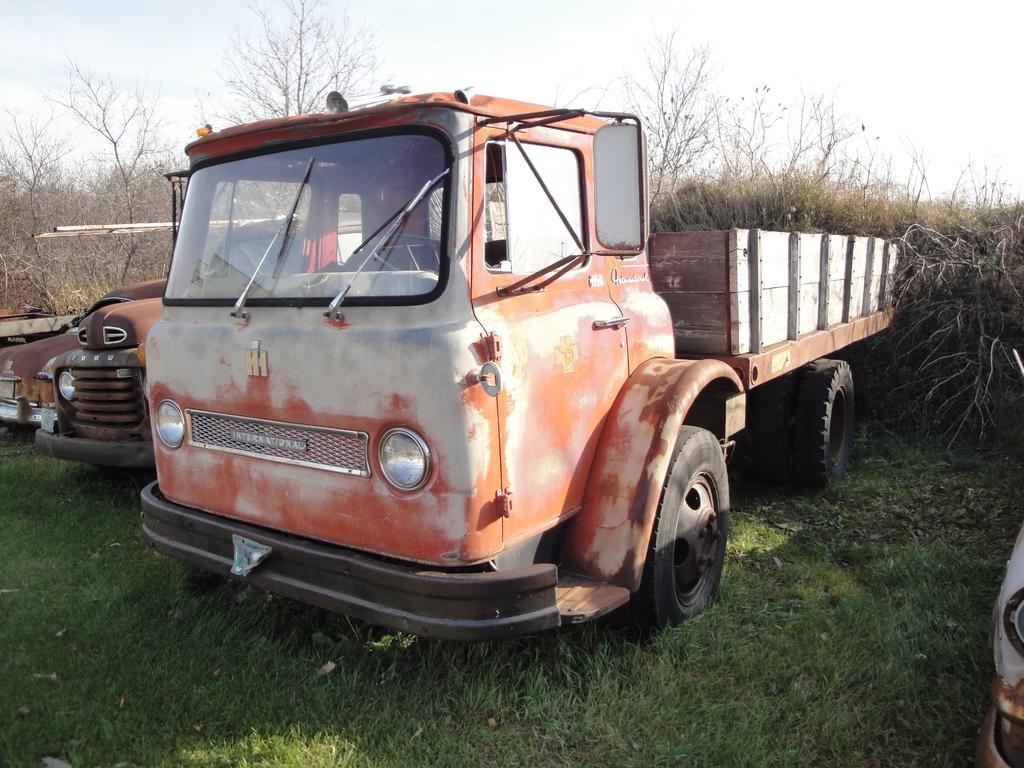Could you give a brief overview of what you see in this image? In this picture we can see vehicles on the ground. Here we can see grass and trees. In the background there is sky. 